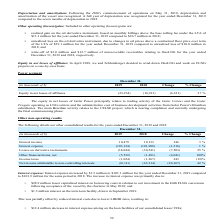From Golar Lng's financial document, In which years was the other consolidated results recorded for? The document shows two values: 2018 and 2019. From the document: "December 31, (in thousands of $) 2019 2018 Change % Change December 31, (in thousands of $) 2019 2018 Change % Change..." Also, What was the reason for the change in other financial items, net? Based on the financial document, the answer is Primarily as a result of consolidating our lessor VIEs.. Also, What accounted for the increase in net income attributable to non-controlling interests? Based on the financial document, the answer is Due to the completion of the Hilli Disposal in July 2018. Additionally, Which year has a higher income tax? According to the financial document, 2018. The relevant text states: "December 31, (in thousands of $) 2019 2018 Change % Change..." Also, can you calculate: What was the change in net unrealized losses on the interest rate swaps? Based on the calculation: -16.5 - 0.6 , the result is -17.1 (in millions). The key data points involved are: 0.6, 16.5. Also, can you calculate: What was the percentage change in net income attributable in relation to the non-controlling shareholders who hold interests in Hilli LLC? To answer this question, I need to perform calculations using the financial data. The calculation is: (36.5 - 19.7)/19.7 , which equals 85.28 (percentage). The key data points involved are: 19.7, 36.5. 